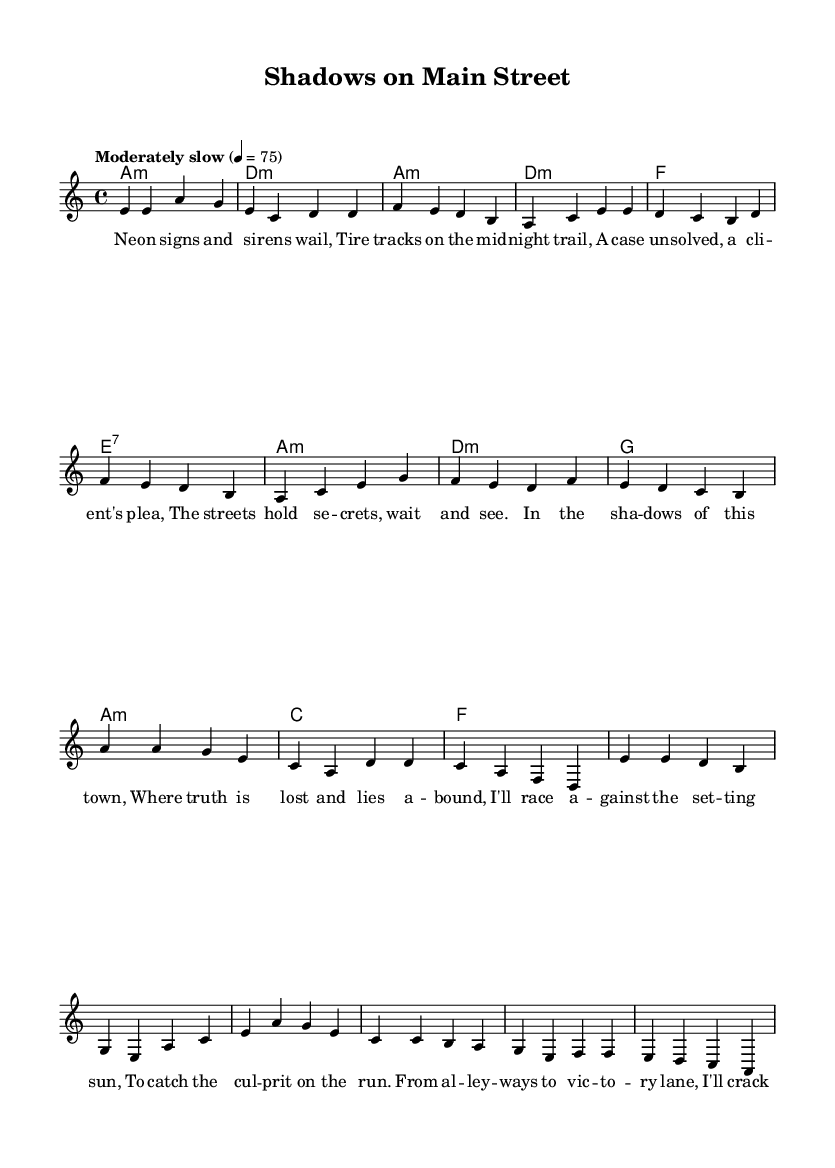What is the key signature of this music? The key signature is indicated at the beginning of the sheet music and shows two flats, which corresponds to the key of A minor.
Answer: A minor What is the time signature of this music? The time signature is noted at the beginning of the sheet music, which is displayed as 4/4. This indicates four beats per measure.
Answer: 4/4 What is the tempo marking for this piece? The tempo marking is indicated at the beginning of the sheet music. It states "Moderately slow" with a metronome marking of 4 = 75, indicating the speed of the music.
Answer: Moderately slow, 75 How many verses are in the song? The lyrics section shows a verse followed by the chorus, and there is only one verse provided before the repetition of the chorus.
Answer: One Which chord appears in the chorus? The chords for the chorus list A minor, D minor, G, and A minor. The answer is found by identifying the chords directly associated with the chorus lyrics.
Answer: A minor What is the lyrical theme of the ballad? The lyrics express themes of crime-solving and uncovering truth in the streets. This can be gathered from the content of the lyrics themselves that mention shadows, truth, and catching a culprit.
Answer: Crime-solving What musical form does the piece follow? The music is structured as a verse-chorus format, as evidenced by the separate sections labeled for verses and choruses. This common format is characteristic of folk ballads.
Answer: Verse-chorus 